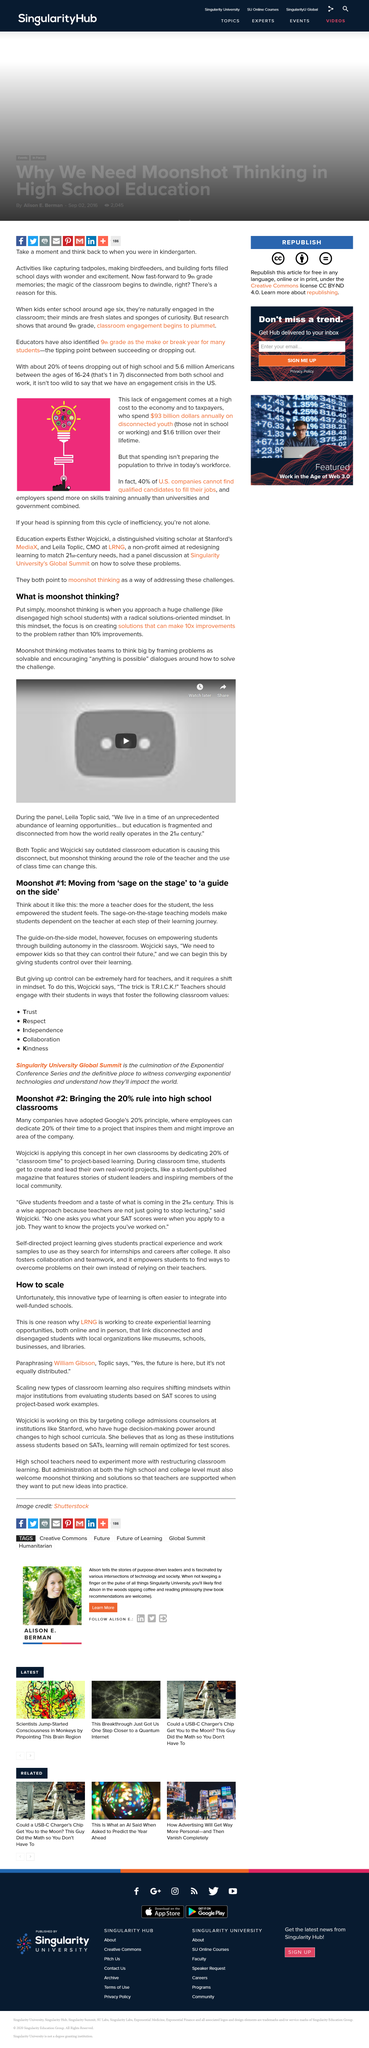Indicate a few pertinent items in this graphic. Moonshot thinking encourages "anything is possible" dialogues, thus promoting a positive and optimistic outlook on problem-solving and achieving seemingly impossible goals. Giving up control requires a shift in mindset, embracing a willingness to let go and trust in the unknown. Annually, the cost of disconnected youth in the US is estimated to be $93 billion. The 20% principle, which was developed by Google, is being applied in the classrooms of Google's CEO, Susan Wojcicki. The quote by William Gibson, 'Yes, the future is here, but it's not equally distributed,' accurately reflects the current state of the future, where its benefits are not equally available to all. 